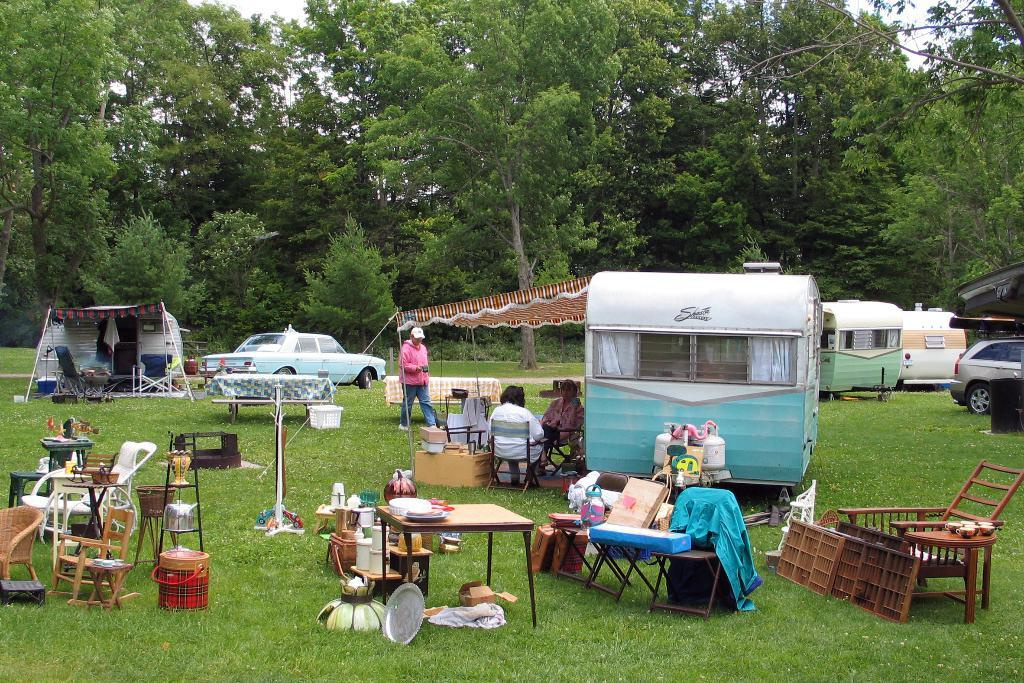What type of furniture is visible in the image? There are tables and chairs in the image. Can you describe the seating arrangement under the tent? Three persons are sitting under a tent. What can be seen in the background of the image? There are trees and cars in the background of the image. What type of hill can be seen in the image? There is no hill present in the image. Can you tell me what is written in the notebook on the table? There is no notebook visible in the image. 